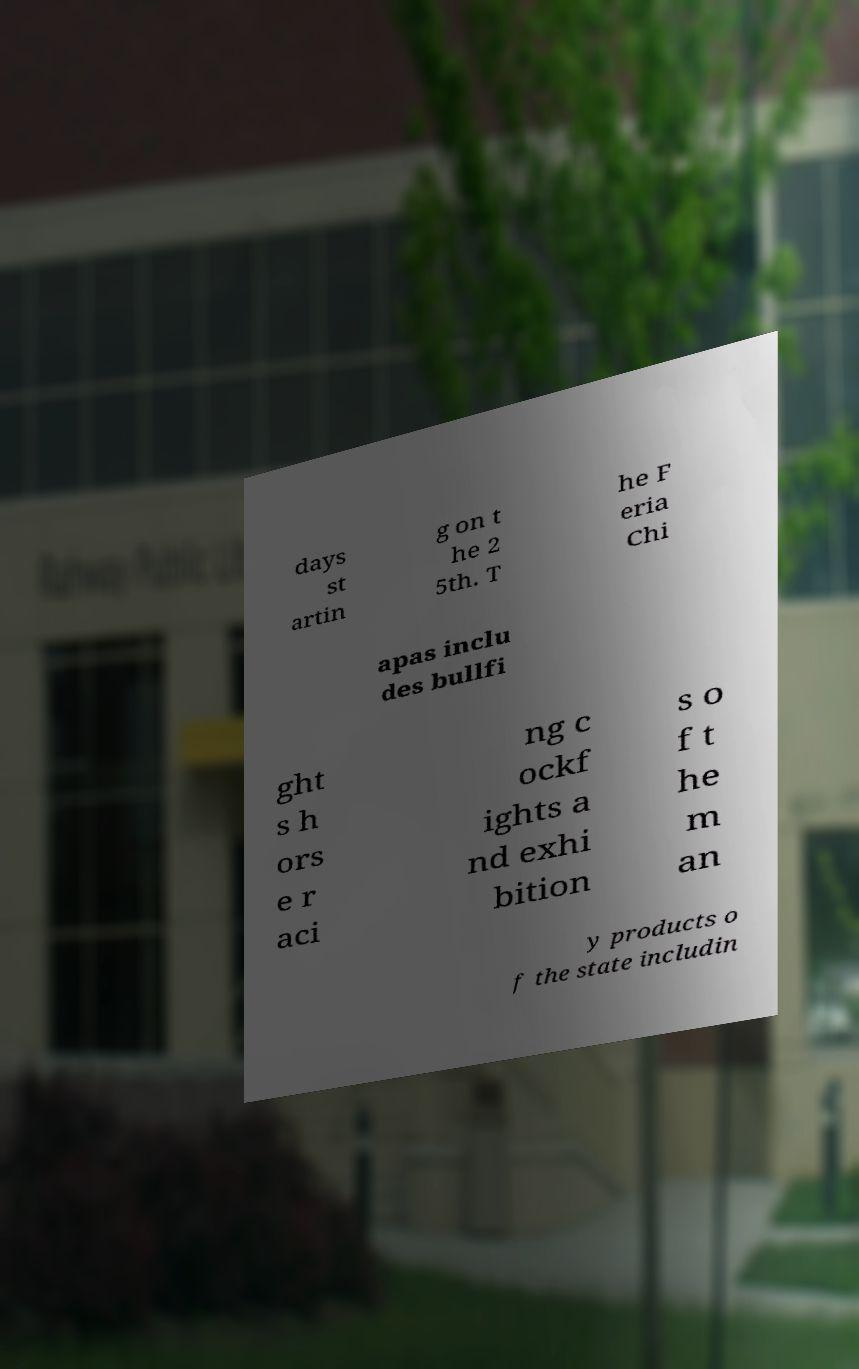Can you read and provide the text displayed in the image?This photo seems to have some interesting text. Can you extract and type it out for me? days st artin g on t he 2 5th. T he F eria Chi apas inclu des bullfi ght s h ors e r aci ng c ockf ights a nd exhi bition s o f t he m an y products o f the state includin 